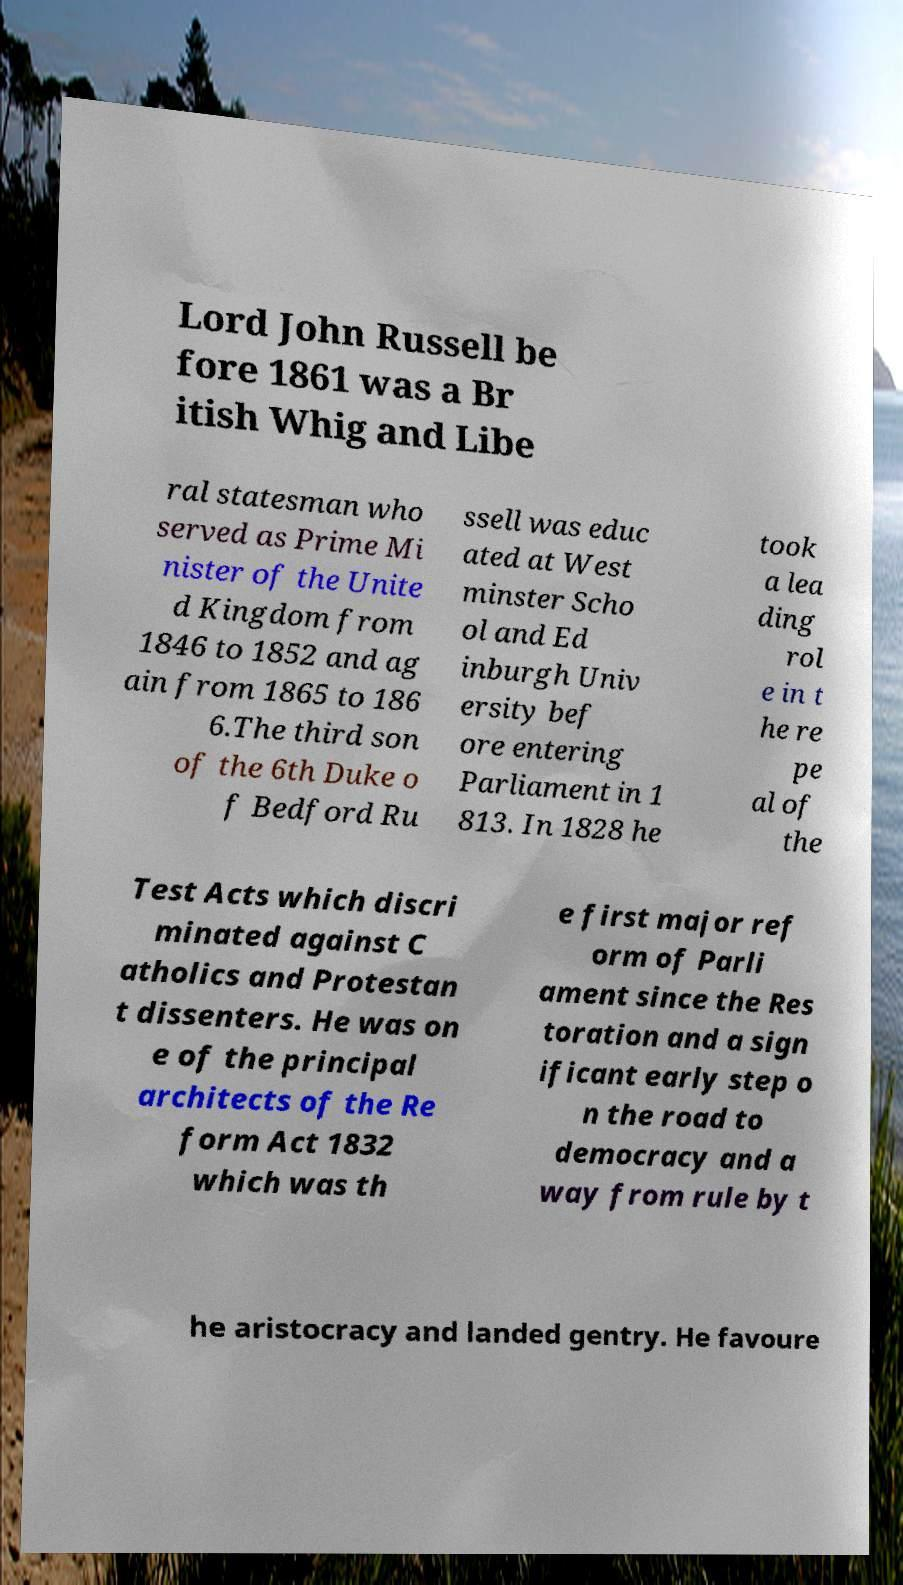For documentation purposes, I need the text within this image transcribed. Could you provide that? Lord John Russell be fore 1861 was a Br itish Whig and Libe ral statesman who served as Prime Mi nister of the Unite d Kingdom from 1846 to 1852 and ag ain from 1865 to 186 6.The third son of the 6th Duke o f Bedford Ru ssell was educ ated at West minster Scho ol and Ed inburgh Univ ersity bef ore entering Parliament in 1 813. In 1828 he took a lea ding rol e in t he re pe al of the Test Acts which discri minated against C atholics and Protestan t dissenters. He was on e of the principal architects of the Re form Act 1832 which was th e first major ref orm of Parli ament since the Res toration and a sign ificant early step o n the road to democracy and a way from rule by t he aristocracy and landed gentry. He favoure 